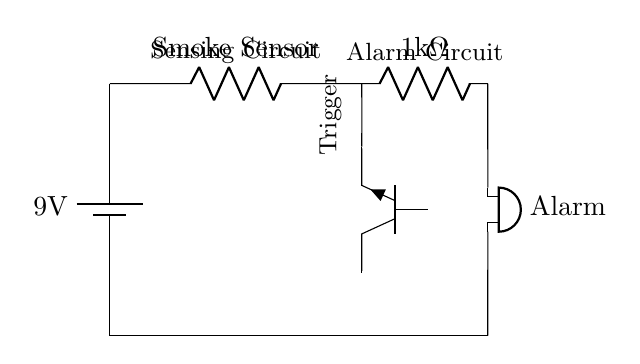What is the voltage of the power supply? The power supply in the circuit is labeled as a 9V battery, indicating that the voltage provided by this source is 9 volts.
Answer: 9V What type of sensor is used in this circuit? The circuit diagram specifies a component labeled as "Smoke Sensor," clearly indicating the type of sensor utilized in the system to detect smoke.
Answer: Smoke Sensor How many resistors are in this circuit? The diagram shows one resistor labeled as 1k ohm connected to the smoke sensor and transistor, making it clear that there is only one resistor in this circuit.
Answer: 1 What type of transistor is used in this circuit? The circuit indicates that an NPN transistor is used, specifying it by the designation "Tnpn" with the label "npn," which identifies the type of transistor present.
Answer: NPN What is connected to the output of the transistor? The output of the transistor connects to a resistor and leads to the alarm, showing that the alarm circuit is activated by the transistor's output when triggered by the smoke sensor.
Answer: Resistor Which component triggers the alarm in this circuit? The smoke sensor is connected to the base of the NPN transistor; when smoke is detected, the sensor triggers the transistor, which then allows current to flow to the buzzer, activating the alarm.
Answer: Smoke Sensor 